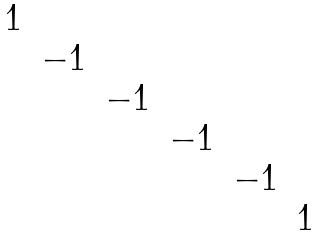Convert formula to latex. <formula><loc_0><loc_0><loc_500><loc_500>\begin{matrix} 1 & & & & & \\ & - 1 & & & & \\ & & - 1 & & & \\ & & & - 1 & & \\ & & & & - 1 & \\ & & & & & 1 \end{matrix}</formula> 